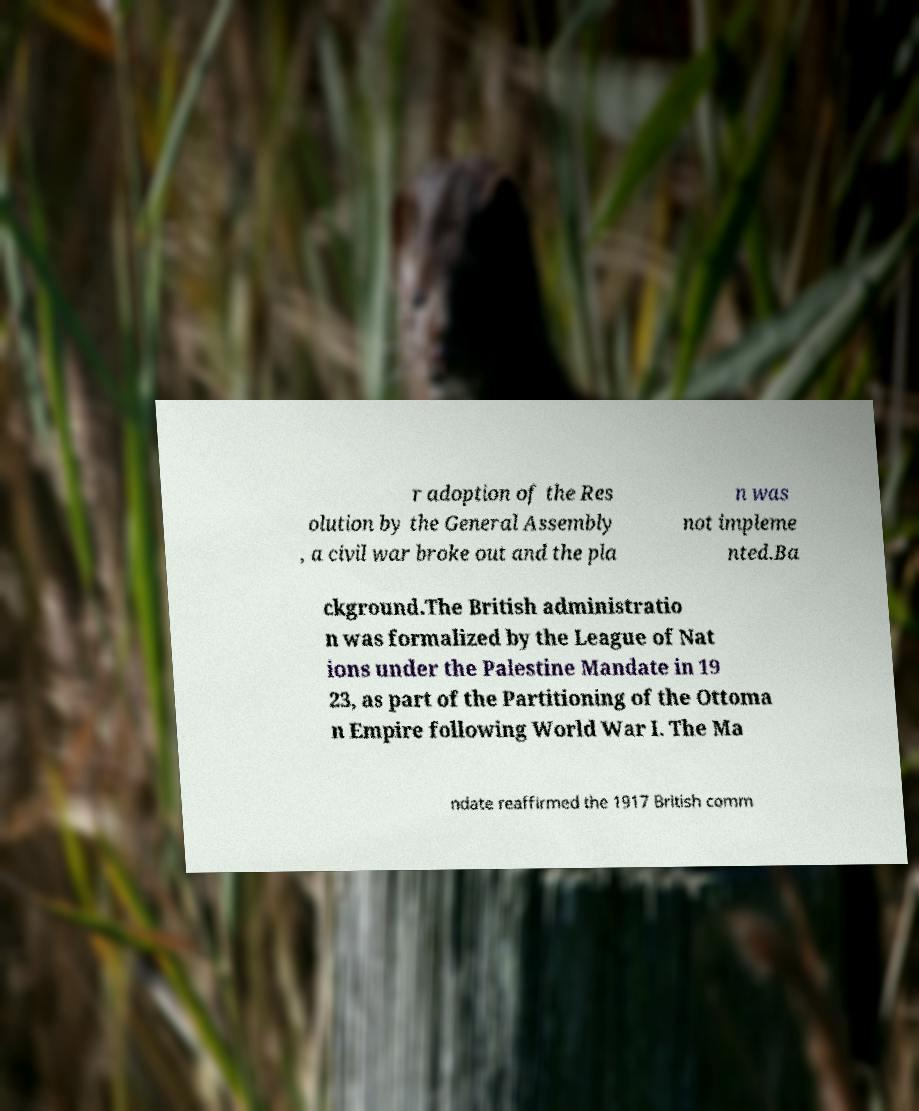For documentation purposes, I need the text within this image transcribed. Could you provide that? r adoption of the Res olution by the General Assembly , a civil war broke out and the pla n was not impleme nted.Ba ckground.The British administratio n was formalized by the League of Nat ions under the Palestine Mandate in 19 23, as part of the Partitioning of the Ottoma n Empire following World War I. The Ma ndate reaffirmed the 1917 British comm 